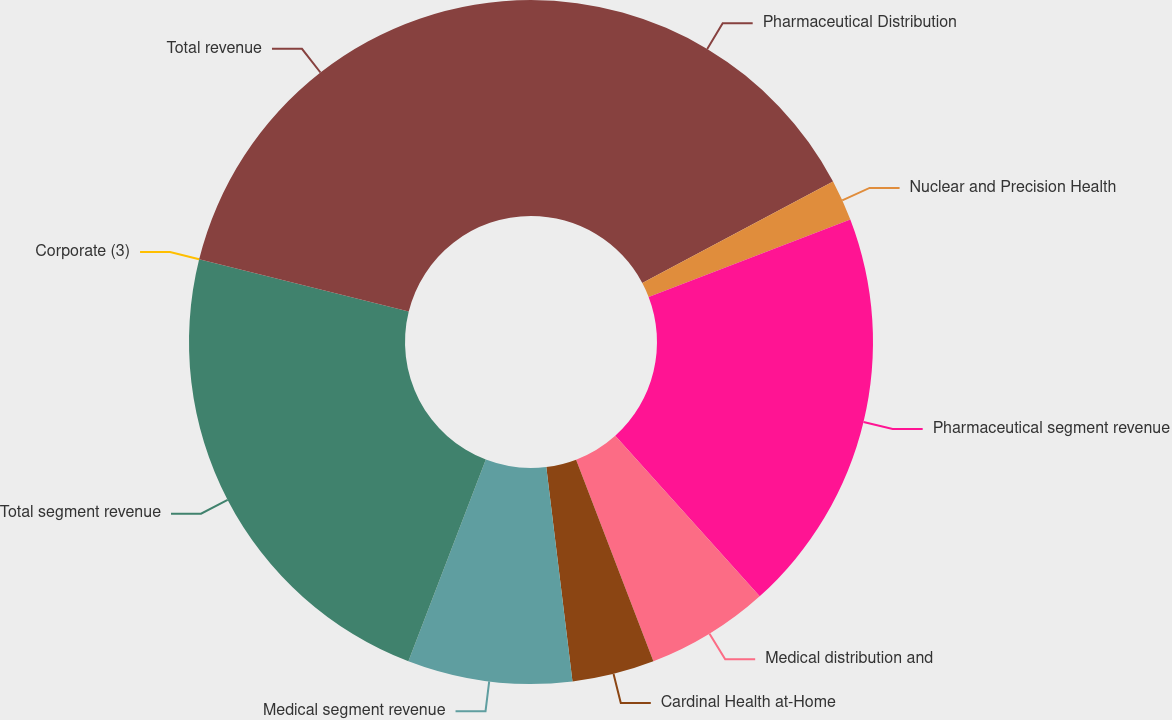Convert chart. <chart><loc_0><loc_0><loc_500><loc_500><pie_chart><fcel>Pharmaceutical Distribution<fcel>Nuclear and Precision Health<fcel>Pharmaceutical segment revenue<fcel>Medical distribution and<fcel>Cardinal Health at-Home<fcel>Medical segment revenue<fcel>Total segment revenue<fcel>Corporate (3)<fcel>Total revenue<nl><fcel>17.23%<fcel>1.94%<fcel>19.17%<fcel>5.83%<fcel>3.89%<fcel>7.77%<fcel>23.05%<fcel>0.0%<fcel>21.11%<nl></chart> 